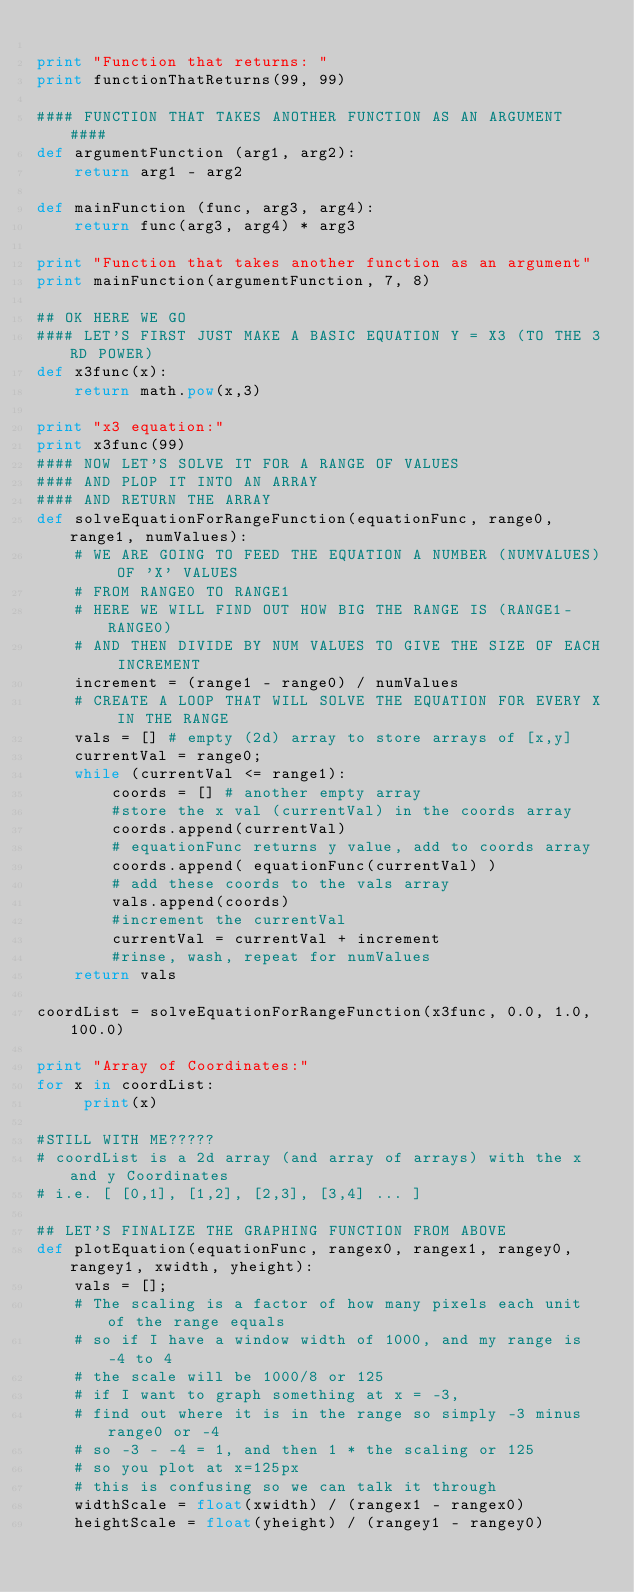Convert code to text. <code><loc_0><loc_0><loc_500><loc_500><_Python_>
print "Function that returns: "
print functionThatReturns(99, 99)

#### FUNCTION THAT TAKES ANOTHER FUNCTION AS AN ARGUMENT ####
def argumentFunction (arg1, arg2):
    return arg1 - arg2

def mainFunction (func, arg3, arg4):
    return func(arg3, arg4) * arg3

print "Function that takes another function as an argument"
print mainFunction(argumentFunction, 7, 8)

## OK HERE WE GO
#### LET'S FIRST JUST MAKE A BASIC EQUATION Y = X3 (TO THE 3RD POWER)
def x3func(x):
    return math.pow(x,3)

print "x3 equation:"
print x3func(99)
#### NOW LET'S SOLVE IT FOR A RANGE OF VALUES
#### AND PLOP IT INTO AN ARRAY
#### AND RETURN THE ARRAY
def solveEquationForRangeFunction(equationFunc, range0, range1, numValues):
    # WE ARE GOING TO FEED THE EQUATION A NUMBER (NUMVALUES) OF 'X' VALUES
    # FROM RANGE0 TO RANGE1
    # HERE WE WILL FIND OUT HOW BIG THE RANGE IS (RANGE1-RANGE0)
    # AND THEN DIVIDE BY NUM VALUES TO GIVE THE SIZE OF EACH INCREMENT
    increment = (range1 - range0) / numValues
    # CREATE A LOOP THAT WILL SOLVE THE EQUATION FOR EVERY X IN THE RANGE
    vals = [] # empty (2d) array to store arrays of [x,y]
    currentVal = range0;
    while (currentVal <= range1):
        coords = [] # another empty array
        #store the x val (currentVal) in the coords array
        coords.append(currentVal)
        # equationFunc returns y value, add to coords array
        coords.append( equationFunc(currentVal) )
        # add these coords to the vals array
        vals.append(coords)
        #increment the currentVal
        currentVal = currentVal + increment
        #rinse, wash, repeat for numValues
    return vals

coordList = solveEquationForRangeFunction(x3func, 0.0, 1.0, 100.0)

print "Array of Coordinates:"
for x in coordList:
     print(x)

#STILL WITH ME?????
# coordList is a 2d array (and array of arrays) with the x and y Coordinates
# i.e. [ [0,1], [1,2], [2,3], [3,4] ... ]

## LET'S FINALIZE THE GRAPHING FUNCTION FROM ABOVE
def plotEquation(equationFunc, rangex0, rangex1, rangey0, rangey1, xwidth, yheight):
    vals = [];
    # The scaling is a factor of how many pixels each unit of the range equals
    # so if I have a window width of 1000, and my range is -4 to 4
    # the scale will be 1000/8 or 125
    # if I want to graph something at x = -3,
    # find out where it is in the range so simply -3 minus range0 or -4
    # so -3 - -4 = 1, and then 1 * the scaling or 125
    # so you plot at x=125px
    # this is confusing so we can talk it through
    widthScale = float(xwidth) / (rangex1 - rangex0)
    heightScale = float(yheight) / (rangey1 - rangey0)</code> 